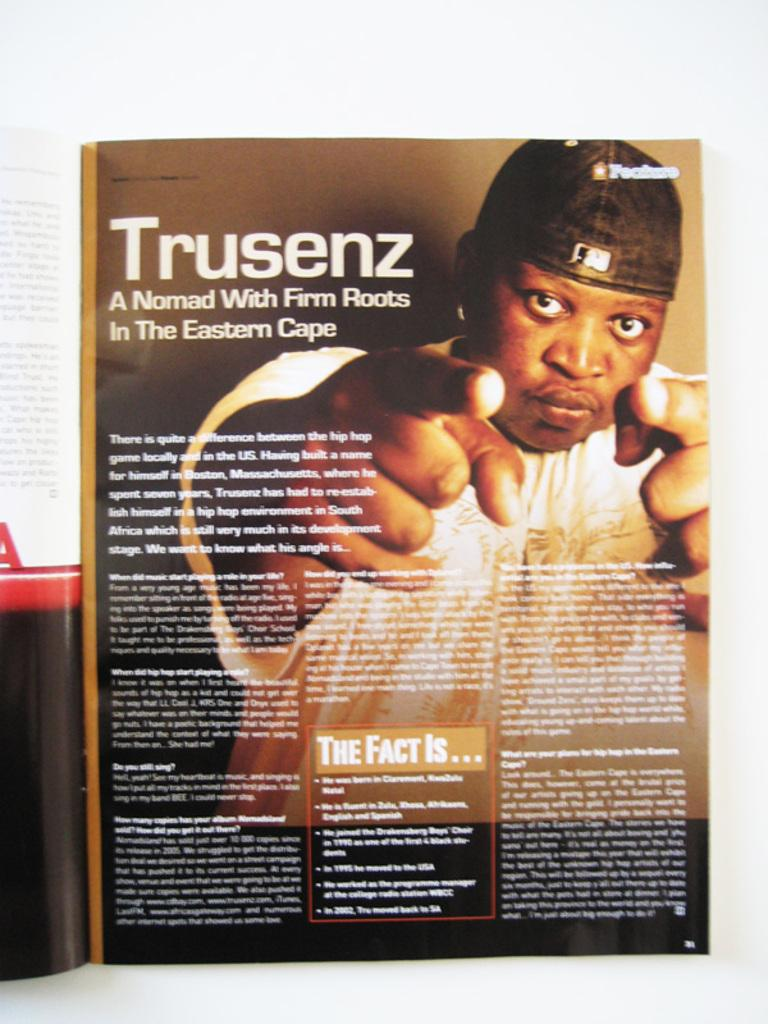What is the primary element in the image? There is a page in the image. What is the color of the background on the page? The page has a white background. What can be seen on the page besides the background? There is a person depicted on the page, and there is text on the page. How many songs can be heard playing in the background of the image? There is no audio or music present in the image, so it is not possible to determine how many songs might be playing. 